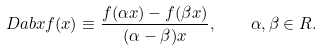Convert formula to latex. <formula><loc_0><loc_0><loc_500><loc_500>\ D a b { x } f ( x ) \equiv \frac { f ( \alpha x ) - f ( \beta x ) } { ( \alpha - \beta ) x } , \quad \alpha , \beta \in R .</formula> 